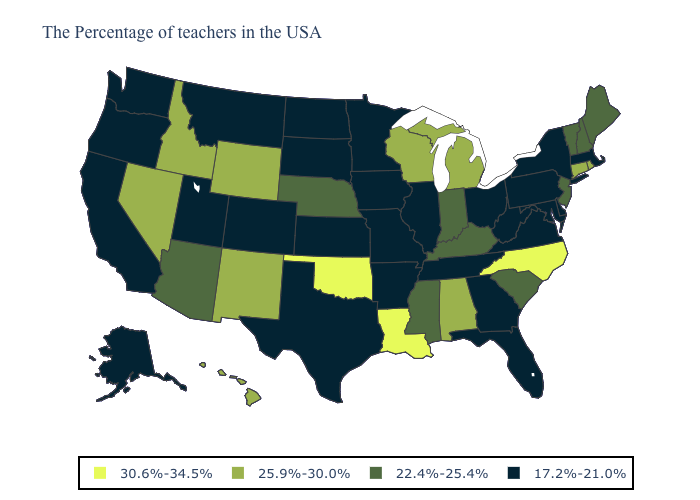What is the value of Montana?
Be succinct. 17.2%-21.0%. Name the states that have a value in the range 22.4%-25.4%?
Answer briefly. Maine, New Hampshire, Vermont, New Jersey, South Carolina, Kentucky, Indiana, Mississippi, Nebraska, Arizona. Among the states that border Florida , which have the highest value?
Quick response, please. Alabama. Among the states that border Alabama , which have the lowest value?
Concise answer only. Florida, Georgia, Tennessee. Name the states that have a value in the range 17.2%-21.0%?
Be succinct. Massachusetts, New York, Delaware, Maryland, Pennsylvania, Virginia, West Virginia, Ohio, Florida, Georgia, Tennessee, Illinois, Missouri, Arkansas, Minnesota, Iowa, Kansas, Texas, South Dakota, North Dakota, Colorado, Utah, Montana, California, Washington, Oregon, Alaska. What is the highest value in states that border North Dakota?
Be succinct. 17.2%-21.0%. Among the states that border North Carolina , does Georgia have the lowest value?
Short answer required. Yes. Name the states that have a value in the range 22.4%-25.4%?
Be succinct. Maine, New Hampshire, Vermont, New Jersey, South Carolina, Kentucky, Indiana, Mississippi, Nebraska, Arizona. Which states have the highest value in the USA?
Give a very brief answer. North Carolina, Louisiana, Oklahoma. Name the states that have a value in the range 30.6%-34.5%?
Quick response, please. North Carolina, Louisiana, Oklahoma. Name the states that have a value in the range 30.6%-34.5%?
Be succinct. North Carolina, Louisiana, Oklahoma. What is the value of South Carolina?
Be succinct. 22.4%-25.4%. What is the highest value in the South ?
Quick response, please. 30.6%-34.5%. Name the states that have a value in the range 22.4%-25.4%?
Answer briefly. Maine, New Hampshire, Vermont, New Jersey, South Carolina, Kentucky, Indiana, Mississippi, Nebraska, Arizona. How many symbols are there in the legend?
Be succinct. 4. 